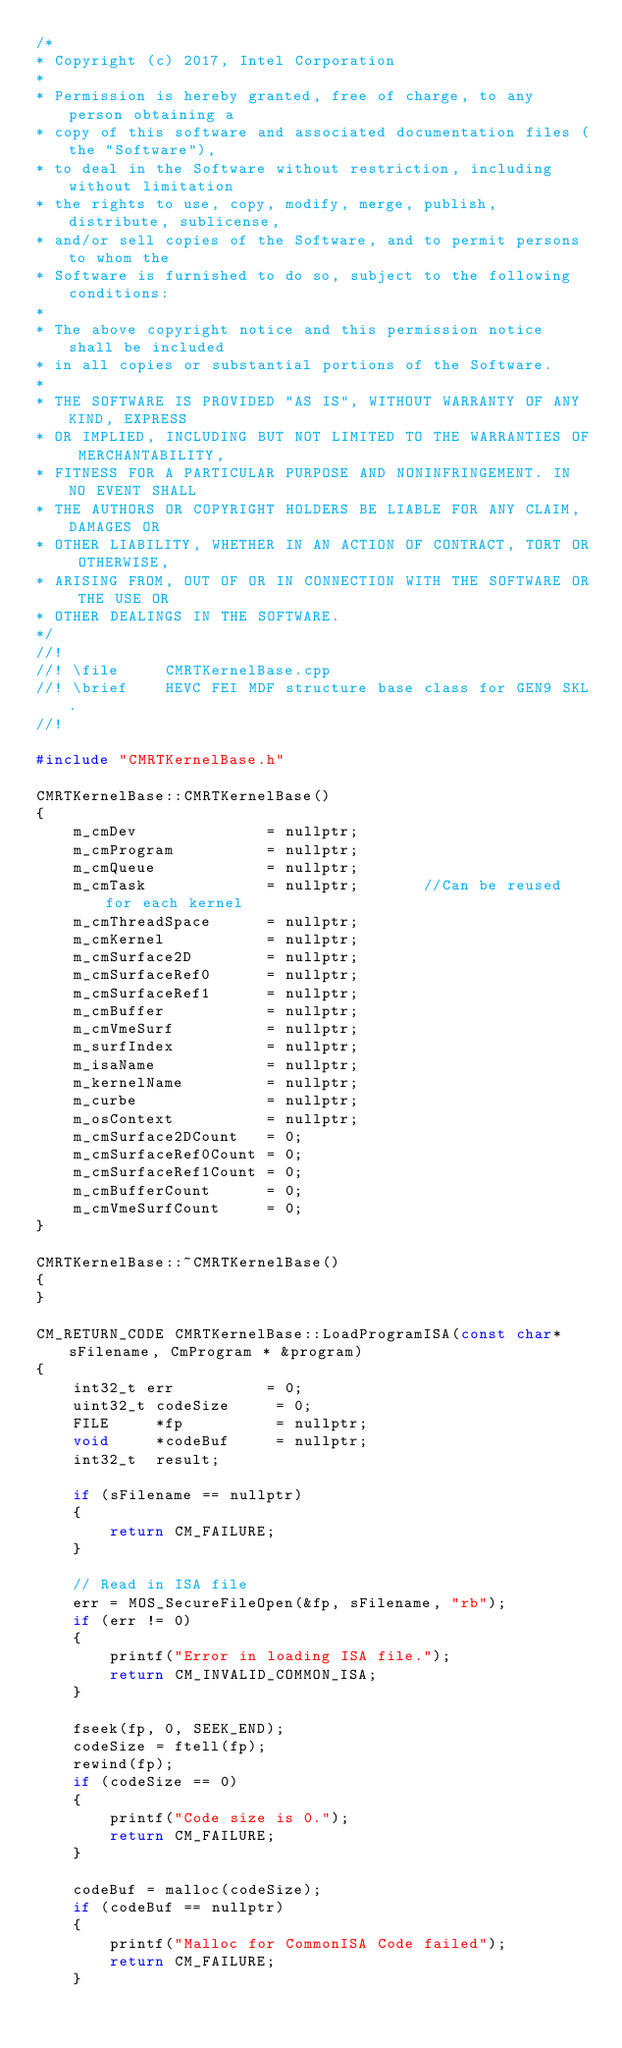<code> <loc_0><loc_0><loc_500><loc_500><_C++_>/*
* Copyright (c) 2017, Intel Corporation
*
* Permission is hereby granted, free of charge, to any person obtaining a
* copy of this software and associated documentation files (the "Software"),
* to deal in the Software without restriction, including without limitation
* the rights to use, copy, modify, merge, publish, distribute, sublicense,
* and/or sell copies of the Software, and to permit persons to whom the
* Software is furnished to do so, subject to the following conditions:
*
* The above copyright notice and this permission notice shall be included
* in all copies or substantial portions of the Software.
*
* THE SOFTWARE IS PROVIDED "AS IS", WITHOUT WARRANTY OF ANY KIND, EXPRESS
* OR IMPLIED, INCLUDING BUT NOT LIMITED TO THE WARRANTIES OF MERCHANTABILITY,
* FITNESS FOR A PARTICULAR PURPOSE AND NONINFRINGEMENT. IN NO EVENT SHALL
* THE AUTHORS OR COPYRIGHT HOLDERS BE LIABLE FOR ANY CLAIM, DAMAGES OR
* OTHER LIABILITY, WHETHER IN AN ACTION OF CONTRACT, TORT OR OTHERWISE,
* ARISING FROM, OUT OF OR IN CONNECTION WITH THE SOFTWARE OR THE USE OR
* OTHER DEALINGS IN THE SOFTWARE.
*/
//!
//! \file     CMRTKernelBase.cpp
//! \brief    HEVC FEI MDF structure base class for GEN9 SKL.
//!

#include "CMRTKernelBase.h"

CMRTKernelBase::CMRTKernelBase()
{
    m_cmDev              = nullptr;
    m_cmProgram          = nullptr;
    m_cmQueue            = nullptr;
    m_cmTask             = nullptr;       //Can be reused for each kernel
    m_cmThreadSpace      = nullptr;
    m_cmKernel           = nullptr;
    m_cmSurface2D        = nullptr;
    m_cmSurfaceRef0      = nullptr;
    m_cmSurfaceRef1      = nullptr;
    m_cmBuffer           = nullptr;
    m_cmVmeSurf          = nullptr;
    m_surfIndex          = nullptr;
    m_isaName            = nullptr;
    m_kernelName         = nullptr;
    m_curbe              = nullptr;
    m_osContext          = nullptr;
    m_cmSurface2DCount   = 0;
    m_cmSurfaceRef0Count = 0;
    m_cmSurfaceRef1Count = 0;
    m_cmBufferCount      = 0;
    m_cmVmeSurfCount     = 0;
}

CMRTKernelBase::~CMRTKernelBase()
{
}

CM_RETURN_CODE CMRTKernelBase::LoadProgramISA(const char* sFilename, CmProgram * &program)
{
    int32_t err          = 0;
    uint32_t codeSize     = 0; 
    FILE     *fp          = nullptr;
    void     *codeBuf     = nullptr;
    int32_t  result; 

    if (sFilename == nullptr)
    {
        return CM_FAILURE;
    }

    // Read in ISA file
    err = MOS_SecureFileOpen(&fp, sFilename, "rb");
    if (err != 0)
    {
        printf("Error in loading ISA file.");
        return CM_INVALID_COMMON_ISA;
    }

    fseek(fp, 0, SEEK_END);
    codeSize = ftell(fp);
    rewind(fp);
    if (codeSize == 0)
    {
        printf("Code size is 0.");
        return CM_FAILURE;
    }

    codeBuf = malloc(codeSize);
    if (codeBuf == nullptr)
    {
        printf("Malloc for CommonISA Code failed");
        return CM_FAILURE;
    }
</code> 